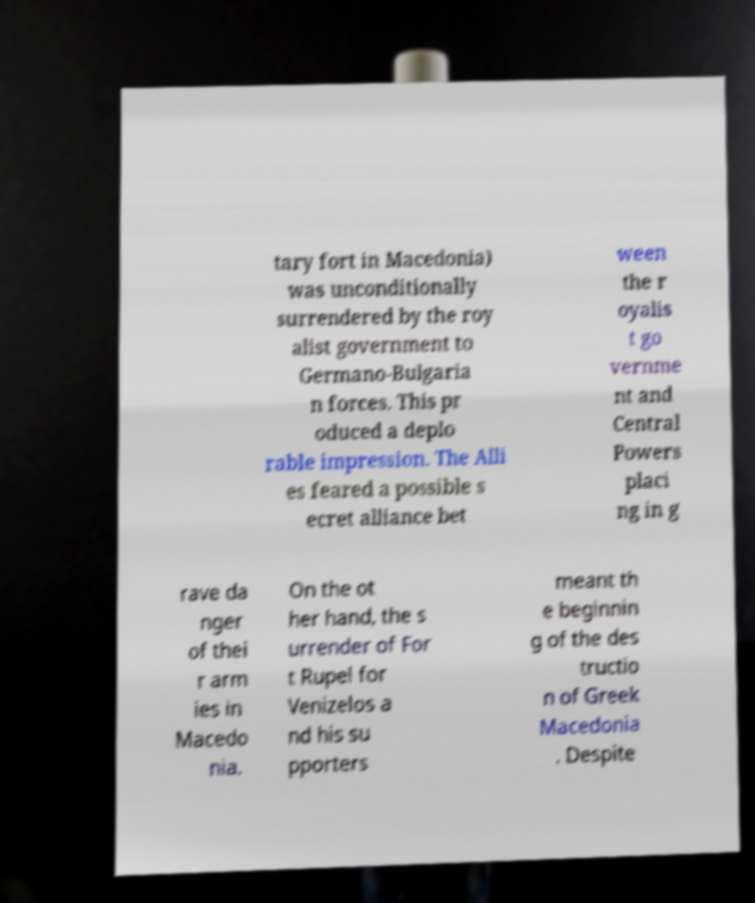Could you assist in decoding the text presented in this image and type it out clearly? tary fort in Macedonia) was unconditionally surrendered by the roy alist government to Germano-Bulgaria n forces. This pr oduced a deplo rable impression. The Alli es feared a possible s ecret alliance bet ween the r oyalis t go vernme nt and Central Powers placi ng in g rave da nger of thei r arm ies in Macedo nia. On the ot her hand, the s urrender of For t Rupel for Venizelos a nd his su pporters meant th e beginnin g of the des tructio n of Greek Macedonia . Despite 